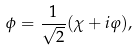<formula> <loc_0><loc_0><loc_500><loc_500>\phi = \frac { 1 } { \sqrt { 2 } } ( \chi + i \varphi ) ,</formula> 